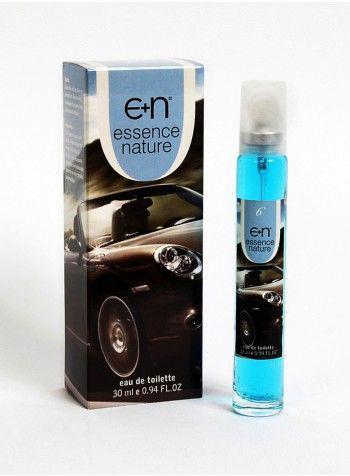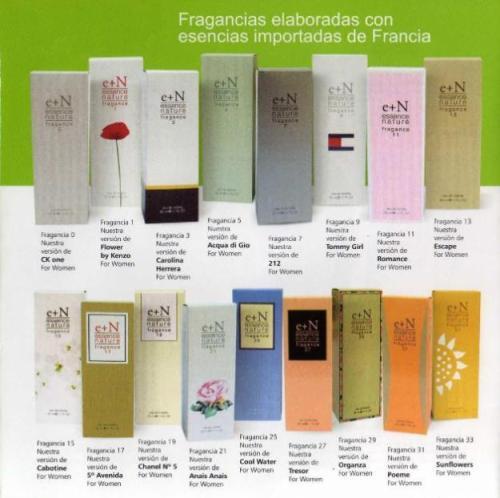The first image is the image on the left, the second image is the image on the right. Evaluate the accuracy of this statement regarding the images: "In one image, a single slender spray bottle stands next to a box with a woman's face on it.". Is it true? Answer yes or no. No. The first image is the image on the left, the second image is the image on the right. For the images shown, is this caption "There is only one tube of product and its box in the image on the left." true? Answer yes or no. Yes. 